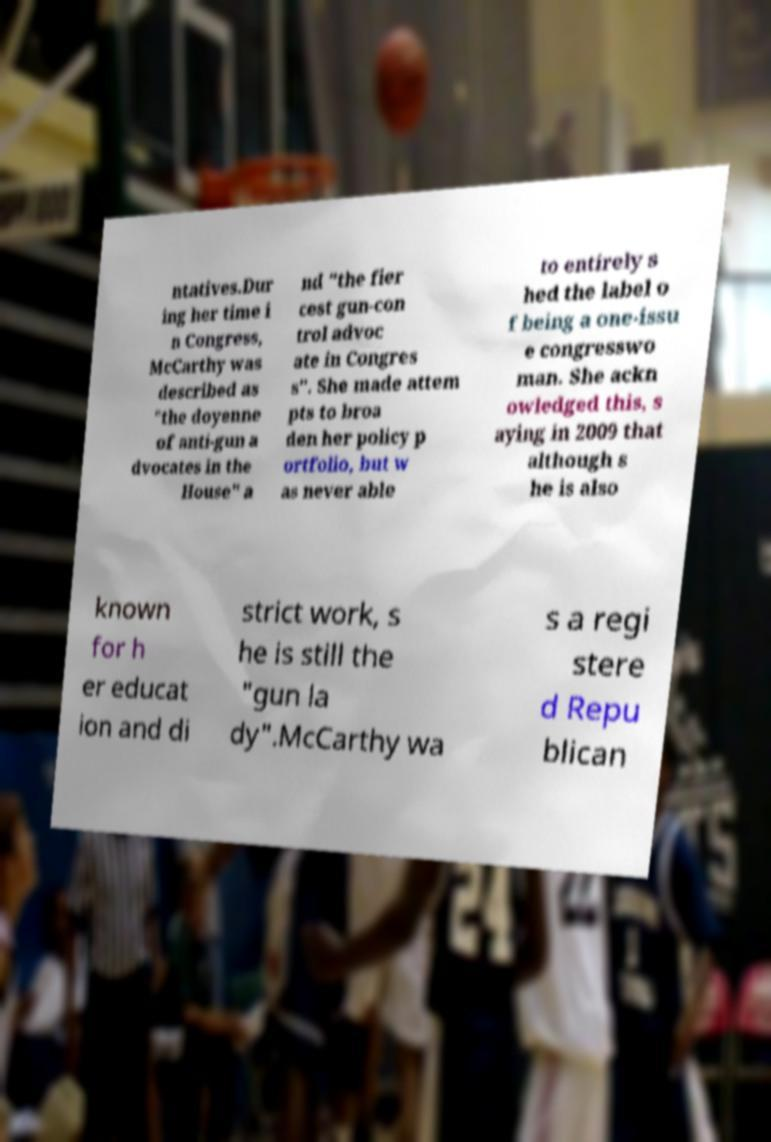Please read and relay the text visible in this image. What does it say? ntatives.Dur ing her time i n Congress, McCarthy was described as "the doyenne of anti-gun a dvocates in the House" a nd "the fier cest gun-con trol advoc ate in Congres s". She made attem pts to broa den her policy p ortfolio, but w as never able to entirely s hed the label o f being a one-issu e congresswo man. She ackn owledged this, s aying in 2009 that although s he is also known for h er educat ion and di strict work, s he is still the "gun la dy".McCarthy wa s a regi stere d Repu blican 